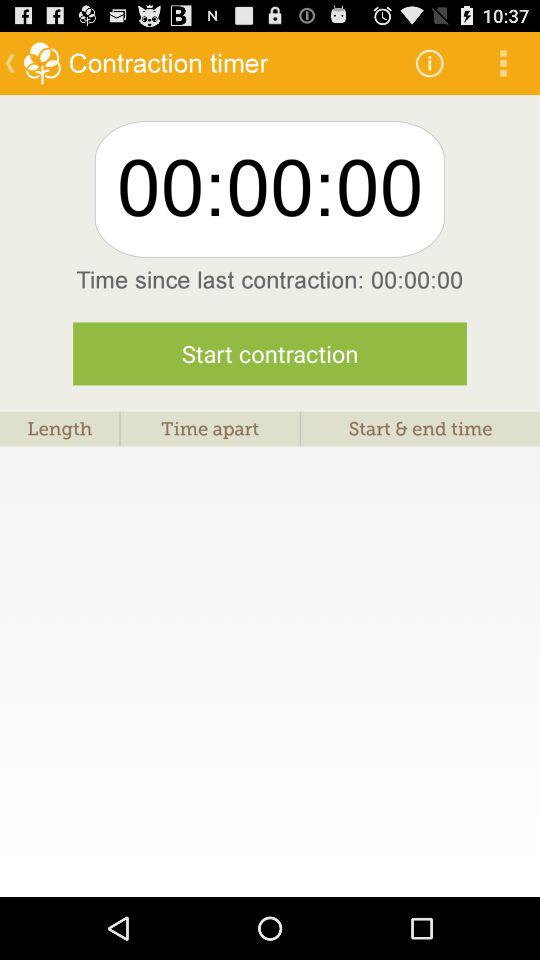How much time has elapsed since the last contraction? The time that has elapsed since the last contraction is 00:00:00. 